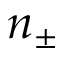Convert formula to latex. <formula><loc_0><loc_0><loc_500><loc_500>n _ { \pm }</formula> 